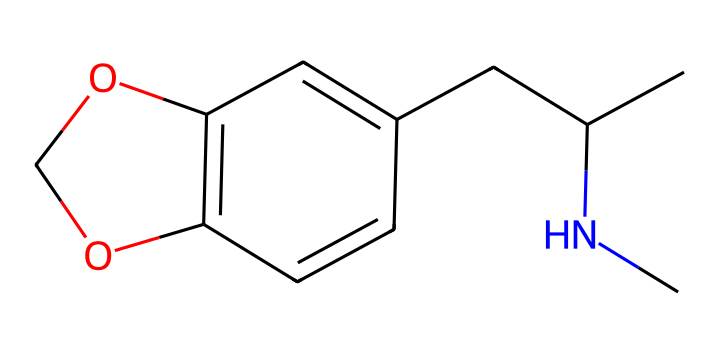What is the main functional group present in this chemical? The chemical structure contains a hydroxyl (–OH) group, which is identified by the oxygen atom connected to hydrogen. This is indicative of the presence of alcohol functionality.
Answer: hydroxyl group How many rings are present in the chemical structure? Analyzing the structure, there are two fused ring systems visible in the chemical. A careful observation of the interconnected carbon atoms confirms this.
Answer: two rings What is the total number of carbon atoms in the structure? By counting the carbon (C) atoms in the SMILES and visualizing the structure, a total of 12 carbon atoms can be confirmed.
Answer: twelve What type of drug category does this structure most likely fall into? Given the presence of the nitrogen atom and the ring structure, this chemical fits the classification of an indole alkaloid, commonly associated with psychoactive effects.
Answer: indole alkaloid What type of rings are present in the structure? The rings found in this chemical structure exhibit a bicyclic arrangement, specifically consisting of a furan and a carbon-based ring. This classification indicates both aromatic properties and varying reactivity patterns.
Answer: bicyclic 